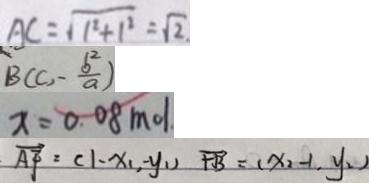<formula> <loc_0><loc_0><loc_500><loc_500>A C = \sqrt { 1 ^ { 2 } + 1 ^ { 2 } } = \sqrt { 2 } . 
 B ( C , - \frac { b ^ { 2 } } { a } ) 
 x = 0 . 0 8 m o l 
 \overrightarrow { A F } = ( 1 - x _ { 1 } , - y _ { 1 ) } \overrightarrow { F B } = ( x _ { 2 } - 1 , y _ { 2 } )</formula> 